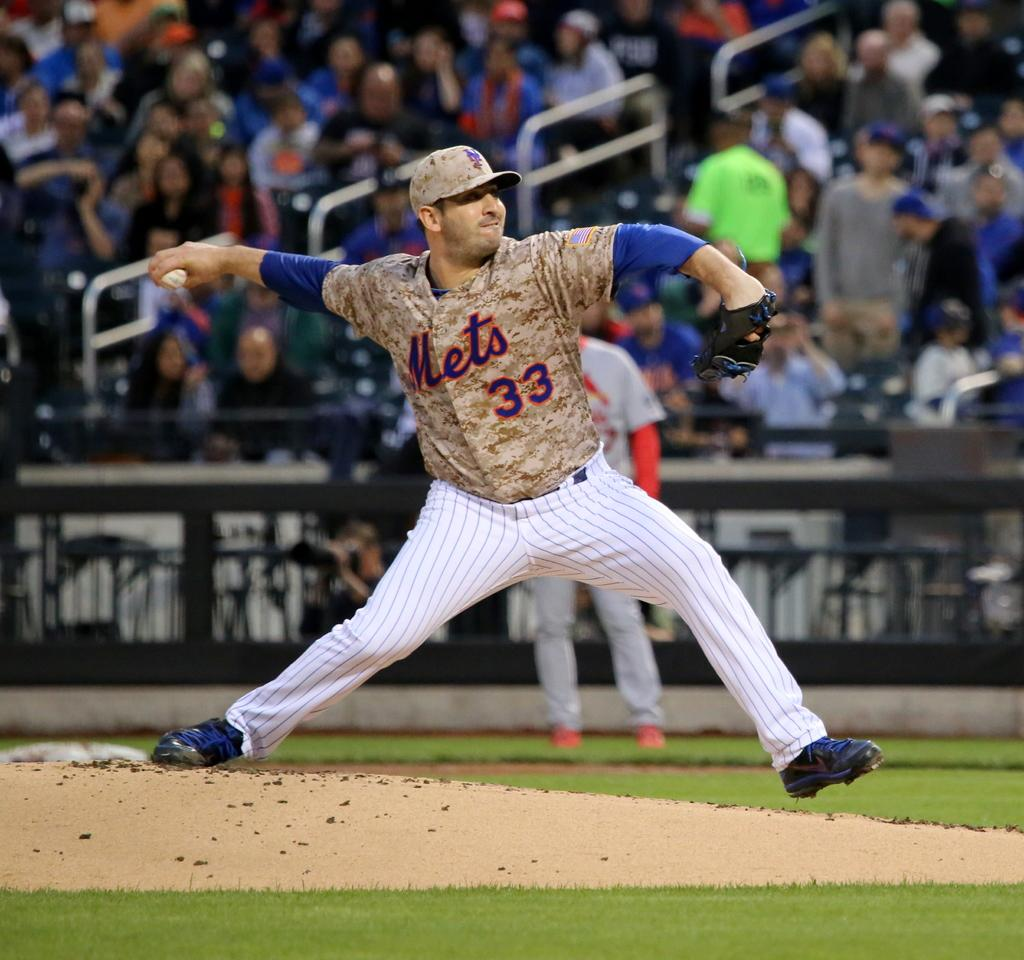<image>
Present a compact description of the photo's key features. Player number 33 for the Mets gets ready to make a ptich 